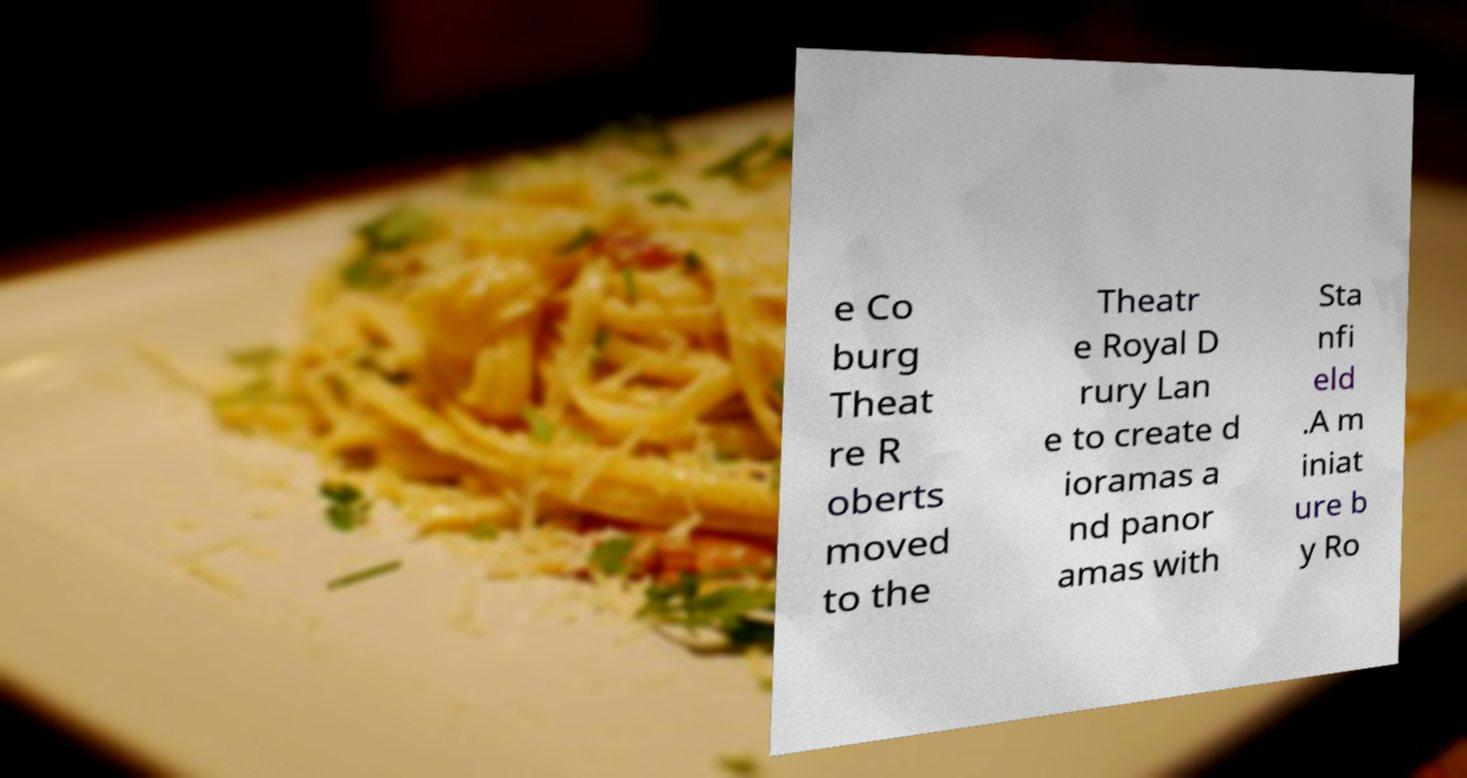Can you accurately transcribe the text from the provided image for me? e Co burg Theat re R oberts moved to the Theatr e Royal D rury Lan e to create d ioramas a nd panor amas with Sta nfi eld .A m iniat ure b y Ro 